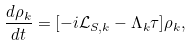<formula> <loc_0><loc_0><loc_500><loc_500>\frac { d \rho _ { k } } { d t } = [ - i \mathcal { \mathcal { L } } _ { S , k } - \Lambda _ { k } \tau ] \rho _ { k } ,</formula> 